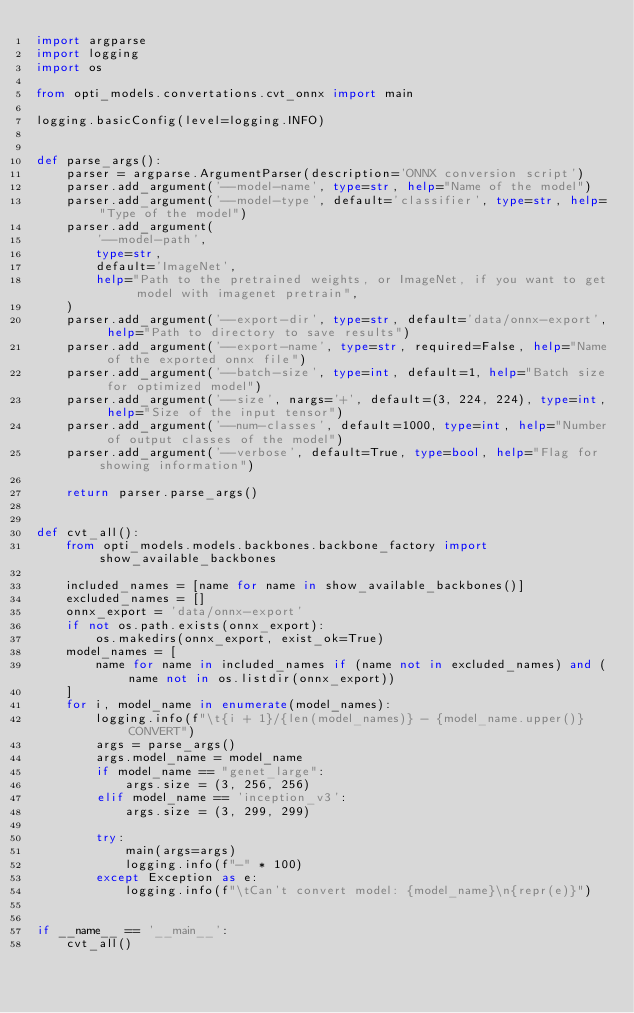<code> <loc_0><loc_0><loc_500><loc_500><_Python_>import argparse
import logging
import os

from opti_models.convertations.cvt_onnx import main

logging.basicConfig(level=logging.INFO)


def parse_args():
    parser = argparse.ArgumentParser(description='ONNX conversion script')
    parser.add_argument('--model-name', type=str, help="Name of the model")
    parser.add_argument('--model-type', default='classifier', type=str, help="Type of the model")
    parser.add_argument(
        '--model-path',
        type=str,
        default='ImageNet',
        help="Path to the pretrained weights, or ImageNet, if you want to get model with imagenet pretrain",
    )
    parser.add_argument('--export-dir', type=str, default='data/onnx-export', help="Path to directory to save results")
    parser.add_argument('--export-name', type=str, required=False, help="Name of the exported onnx file")
    parser.add_argument('--batch-size', type=int, default=1, help="Batch size for optimized model")
    parser.add_argument('--size', nargs='+', default=(3, 224, 224), type=int, help="Size of the input tensor")
    parser.add_argument('--num-classes', default=1000, type=int, help="Number of output classes of the model")
    parser.add_argument('--verbose', default=True, type=bool, help="Flag for showing information")

    return parser.parse_args()


def cvt_all():
    from opti_models.models.backbones.backbone_factory import show_available_backbones

    included_names = [name for name in show_available_backbones()]
    excluded_names = []
    onnx_export = 'data/onnx-export'
    if not os.path.exists(onnx_export):
        os.makedirs(onnx_export, exist_ok=True)
    model_names = [
        name for name in included_names if (name not in excluded_names) and (name not in os.listdir(onnx_export))
    ]
    for i, model_name in enumerate(model_names):
        logging.info(f"\t{i + 1}/{len(model_names)} - {model_name.upper()} CONVERT")
        args = parse_args()
        args.model_name = model_name
        if model_name == "genet_large":
            args.size = (3, 256, 256)
        elif model_name == 'inception_v3':
            args.size = (3, 299, 299)

        try:
            main(args=args)
            logging.info(f"-" * 100)
        except Exception as e:
            logging.info(f"\tCan't convert model: {model_name}\n{repr(e)}")


if __name__ == '__main__':
    cvt_all()
</code> 